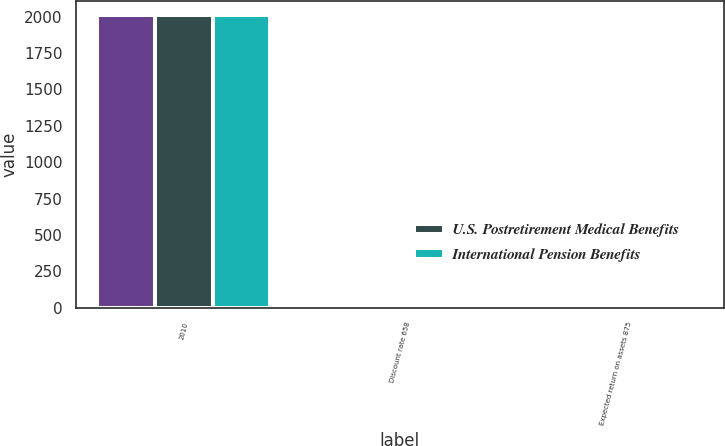Convert chart. <chart><loc_0><loc_0><loc_500><loc_500><stacked_bar_chart><ecel><fcel>2010<fcel>Discount rate 658<fcel>Expected return on assets 875<nl><fcel>nan<fcel>2009<fcel>6.75<fcel>8.96<nl><fcel>U.S. Postretirement Medical Benefits<fcel>2010<fcel>6.43<fcel>8.75<nl><fcel>International Pension Benefits<fcel>2010<fcel>5.84<fcel>7.25<nl></chart> 